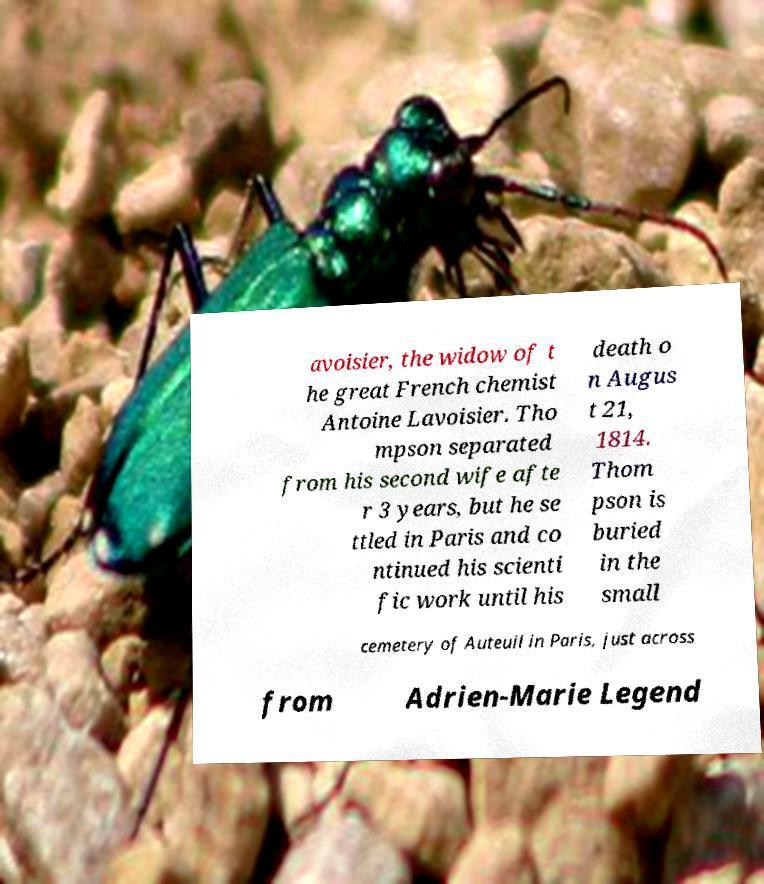Can you accurately transcribe the text from the provided image for me? avoisier, the widow of t he great French chemist Antoine Lavoisier. Tho mpson separated from his second wife afte r 3 years, but he se ttled in Paris and co ntinued his scienti fic work until his death o n Augus t 21, 1814. Thom pson is buried in the small cemetery of Auteuil in Paris, just across from Adrien-Marie Legend 